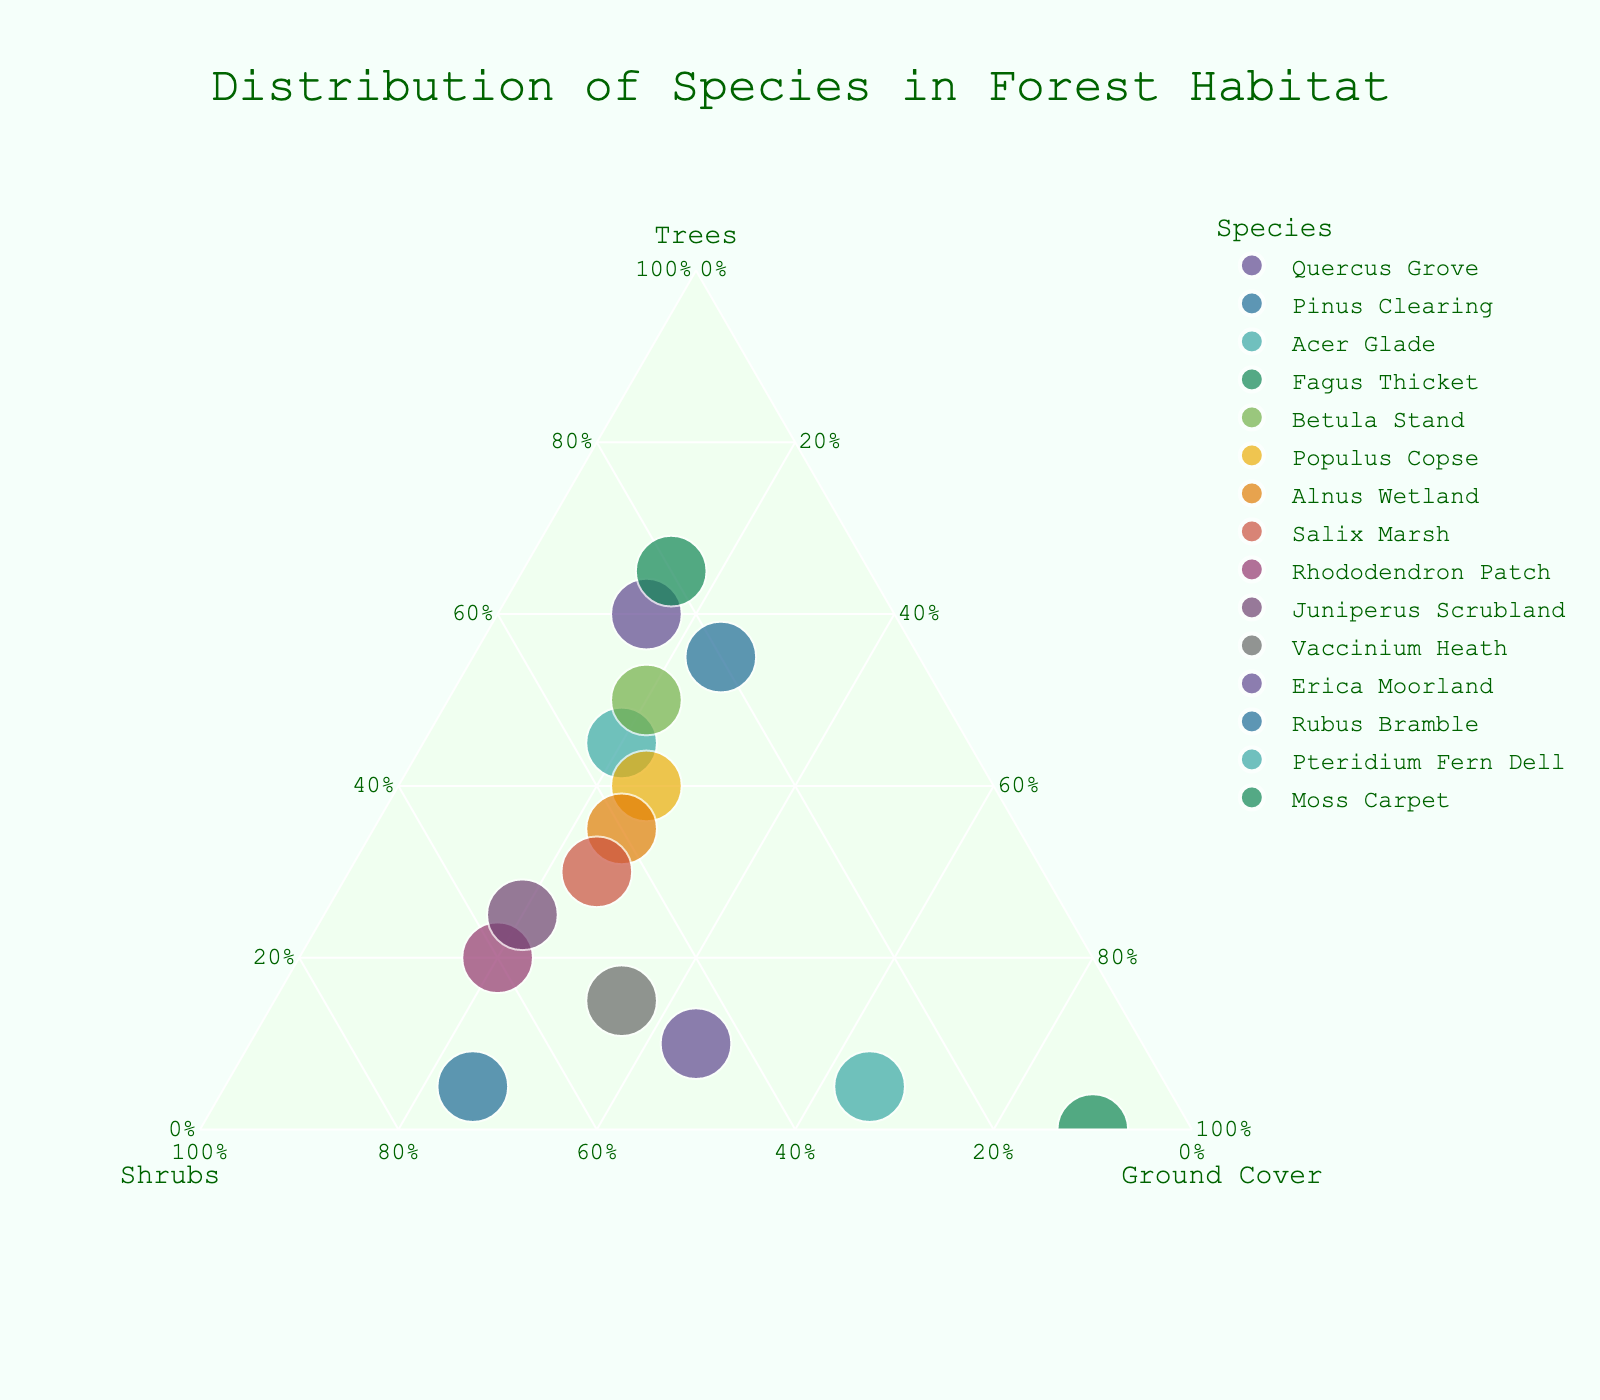Which species has the highest proportion of trees? The species with the highest proportion of trees is the one closest to the "Trees" axis of the ternary plot. Fagus Thicket appears closest to this axis.
Answer: Fagus Thicket Which species has the highest total vegetation cover? The total vegetation cover can be determined by the size of the point in the plot. Rhododendron Patch has a notably large marker size.
Answer: Rhododendron Patch How many species have a higher proportion of shrubs than Quercus Grove? Quercus Grove has 25% shrubs. Count the species that have a point positioned further towards the "Shrubs" axis than Quercus Grove. These species are: Acer Glade, Betula Stand, Populus Copse, Alnus Wetland, Salix Marsh, Rhododendron Patch, Juniperus Scrubland, Vaccinium Heath, Erica Moorland, Rubus Bramble, Pteridium Fern Dell, and Moss Carpet.
Answer: 12 Which species equally share its proportion among trees, shrubs, and ground cover? The species that equally share proportions among trees, shrubs, and ground cover should be positioned near the center of the ternary plot. None of the species sit right at the center of the plot.
Answer: None Compare the proportions of shrubs in Rhododendron Patch and Juniperus Scrubland. Which one has more? Rhododendron Patch has 60% shrubs while Juniperus Scrubland has 55% shrubs. Thus, Rhododendron Patch has more.
Answer: Rhododendron Patch Which species is represented by the smallest point in the plot? The smallest point corresponds to the species with the lowest total vegetation cover. Moss Carpet has the smallest point size.
Answer: Moss Carpet What is the proportion of ground cover in Vaccinium Heath? Vaccinium Heath's point is close to the ground cover axis. From the data provided, its proportion of ground cover is 35%.
Answer: 35% Which two species have the same proportion of trees? From the data, Quercus Grove and Fagus Thicket both have 60% trees. Looking at the plot, these two species have points at the same position along the "Trees" axis.
Answer: Quercus Grove and Fagus Thicket What is the dominant vegetation type in Pteridium Fern Dell? Observing the plot, the point for Pteridium Fern Dell is closest to the "Ground Cover" axis. The data shows it has 65% ground cover, making it the dominant vegetation type.
Answer: Ground Cover How does Alnus Wetland compare to Salix Marsh in terms of shrubbery proportion? Alnus Wetland has 40% shrubs and Salix Marsh has 45% shrubs. Observing their positions in the ternary plot along the "Shrubs" axis, Salix Marsh has a higher proportion of shrubs.
Answer: Salix Marsh 